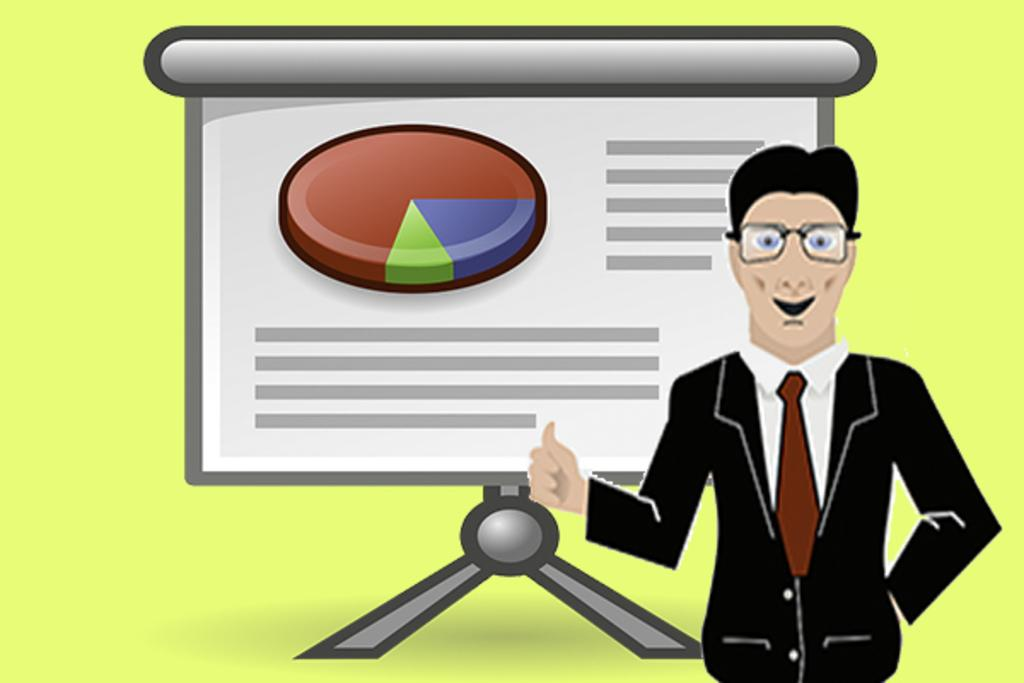What is the main subject of the image? There is a person standing in the image. What is the person wearing? The person is wearing a black dress. What can be seen in the background of the image? There is a screen visible in the background. What is the color of the background? The background color is green. What type of jam is being spread on the bean in the image? There is no jam or bean present in the image; it features a person standing in front of a green background with a screen visible in the background. 